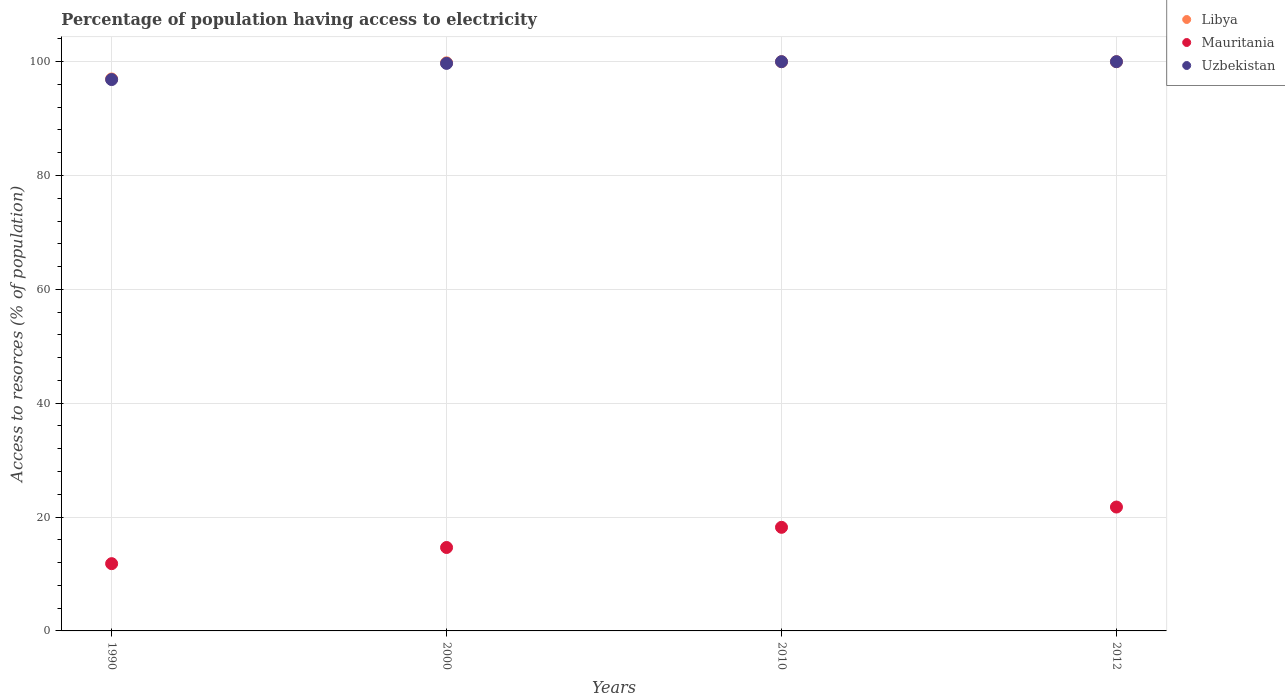How many different coloured dotlines are there?
Offer a terse response. 3. What is the percentage of population having access to electricity in Mauritania in 2000?
Provide a succinct answer. 14.66. Across all years, what is the maximum percentage of population having access to electricity in Libya?
Provide a succinct answer. 100. Across all years, what is the minimum percentage of population having access to electricity in Libya?
Give a very brief answer. 96.96. In which year was the percentage of population having access to electricity in Uzbekistan minimum?
Your answer should be compact. 1990. What is the total percentage of population having access to electricity in Mauritania in the graph?
Ensure brevity in your answer.  66.43. What is the difference between the percentage of population having access to electricity in Uzbekistan in 1990 and that in 2000?
Keep it short and to the point. -2.84. What is the difference between the percentage of population having access to electricity in Libya in 1990 and the percentage of population having access to electricity in Mauritania in 2010?
Give a very brief answer. 78.76. What is the average percentage of population having access to electricity in Libya per year?
Offer a very short reply. 99.19. In the year 2010, what is the difference between the percentage of population having access to electricity in Libya and percentage of population having access to electricity in Mauritania?
Your answer should be very brief. 81.8. What is the ratio of the percentage of population having access to electricity in Libya in 1990 to that in 2010?
Your answer should be very brief. 0.97. Is the percentage of population having access to electricity in Uzbekistan in 2000 less than that in 2010?
Offer a terse response. Yes. Is the difference between the percentage of population having access to electricity in Libya in 2000 and 2012 greater than the difference between the percentage of population having access to electricity in Mauritania in 2000 and 2012?
Provide a succinct answer. Yes. What is the difference between the highest and the lowest percentage of population having access to electricity in Uzbekistan?
Provide a short and direct response. 3.14. In how many years, is the percentage of population having access to electricity in Mauritania greater than the average percentage of population having access to electricity in Mauritania taken over all years?
Offer a terse response. 2. Is it the case that in every year, the sum of the percentage of population having access to electricity in Mauritania and percentage of population having access to electricity in Libya  is greater than the percentage of population having access to electricity in Uzbekistan?
Your response must be concise. Yes. Does the percentage of population having access to electricity in Mauritania monotonically increase over the years?
Your answer should be very brief. Yes. Is the percentage of population having access to electricity in Uzbekistan strictly greater than the percentage of population having access to electricity in Libya over the years?
Your response must be concise. No. Is the percentage of population having access to electricity in Mauritania strictly less than the percentage of population having access to electricity in Uzbekistan over the years?
Provide a short and direct response. Yes. How many dotlines are there?
Make the answer very short. 3. Where does the legend appear in the graph?
Offer a very short reply. Top right. What is the title of the graph?
Ensure brevity in your answer.  Percentage of population having access to electricity. Does "Latin America(developing only)" appear as one of the legend labels in the graph?
Ensure brevity in your answer.  No. What is the label or title of the X-axis?
Provide a short and direct response. Years. What is the label or title of the Y-axis?
Offer a terse response. Access to resorces (% of population). What is the Access to resorces (% of population) in Libya in 1990?
Offer a very short reply. 96.96. What is the Access to resorces (% of population) in Mauritania in 1990?
Make the answer very short. 11.82. What is the Access to resorces (% of population) of Uzbekistan in 1990?
Provide a succinct answer. 96.86. What is the Access to resorces (% of population) of Libya in 2000?
Your answer should be compact. 99.8. What is the Access to resorces (% of population) in Mauritania in 2000?
Ensure brevity in your answer.  14.66. What is the Access to resorces (% of population) in Uzbekistan in 2000?
Give a very brief answer. 99.7. What is the Access to resorces (% of population) of Libya in 2010?
Your response must be concise. 100. What is the Access to resorces (% of population) in Mauritania in 2010?
Your answer should be compact. 18.2. What is the Access to resorces (% of population) in Uzbekistan in 2010?
Your answer should be compact. 100. What is the Access to resorces (% of population) in Mauritania in 2012?
Keep it short and to the point. 21.76. What is the Access to resorces (% of population) of Uzbekistan in 2012?
Offer a very short reply. 100. Across all years, what is the maximum Access to resorces (% of population) in Libya?
Keep it short and to the point. 100. Across all years, what is the maximum Access to resorces (% of population) in Mauritania?
Your answer should be compact. 21.76. Across all years, what is the maximum Access to resorces (% of population) in Uzbekistan?
Provide a short and direct response. 100. Across all years, what is the minimum Access to resorces (% of population) of Libya?
Provide a short and direct response. 96.96. Across all years, what is the minimum Access to resorces (% of population) of Mauritania?
Make the answer very short. 11.82. Across all years, what is the minimum Access to resorces (% of population) in Uzbekistan?
Make the answer very short. 96.86. What is the total Access to resorces (% of population) of Libya in the graph?
Give a very brief answer. 396.76. What is the total Access to resorces (% of population) in Mauritania in the graph?
Keep it short and to the point. 66.43. What is the total Access to resorces (% of population) of Uzbekistan in the graph?
Your answer should be very brief. 396.56. What is the difference between the Access to resorces (% of population) in Libya in 1990 and that in 2000?
Offer a terse response. -2.84. What is the difference between the Access to resorces (% of population) in Mauritania in 1990 and that in 2000?
Give a very brief answer. -2.84. What is the difference between the Access to resorces (% of population) in Uzbekistan in 1990 and that in 2000?
Your response must be concise. -2.84. What is the difference between the Access to resorces (% of population) of Libya in 1990 and that in 2010?
Your answer should be very brief. -3.04. What is the difference between the Access to resorces (% of population) in Mauritania in 1990 and that in 2010?
Offer a very short reply. -6.38. What is the difference between the Access to resorces (% of population) in Uzbekistan in 1990 and that in 2010?
Provide a short and direct response. -3.14. What is the difference between the Access to resorces (% of population) in Libya in 1990 and that in 2012?
Your answer should be compact. -3.04. What is the difference between the Access to resorces (% of population) of Mauritania in 1990 and that in 2012?
Give a very brief answer. -9.95. What is the difference between the Access to resorces (% of population) in Uzbekistan in 1990 and that in 2012?
Ensure brevity in your answer.  -3.14. What is the difference between the Access to resorces (% of population) of Libya in 2000 and that in 2010?
Your answer should be very brief. -0.2. What is the difference between the Access to resorces (% of population) of Mauritania in 2000 and that in 2010?
Ensure brevity in your answer.  -3.54. What is the difference between the Access to resorces (% of population) in Mauritania in 2000 and that in 2012?
Provide a succinct answer. -7.11. What is the difference between the Access to resorces (% of population) of Uzbekistan in 2000 and that in 2012?
Ensure brevity in your answer.  -0.3. What is the difference between the Access to resorces (% of population) in Libya in 2010 and that in 2012?
Give a very brief answer. 0. What is the difference between the Access to resorces (% of population) of Mauritania in 2010 and that in 2012?
Ensure brevity in your answer.  -3.56. What is the difference between the Access to resorces (% of population) of Libya in 1990 and the Access to resorces (% of population) of Mauritania in 2000?
Keep it short and to the point. 82.3. What is the difference between the Access to resorces (% of population) in Libya in 1990 and the Access to resorces (% of population) in Uzbekistan in 2000?
Give a very brief answer. -2.74. What is the difference between the Access to resorces (% of population) in Mauritania in 1990 and the Access to resorces (% of population) in Uzbekistan in 2000?
Ensure brevity in your answer.  -87.88. What is the difference between the Access to resorces (% of population) in Libya in 1990 and the Access to resorces (% of population) in Mauritania in 2010?
Your response must be concise. 78.76. What is the difference between the Access to resorces (% of population) in Libya in 1990 and the Access to resorces (% of population) in Uzbekistan in 2010?
Provide a succinct answer. -3.04. What is the difference between the Access to resorces (% of population) in Mauritania in 1990 and the Access to resorces (% of population) in Uzbekistan in 2010?
Provide a short and direct response. -88.18. What is the difference between the Access to resorces (% of population) in Libya in 1990 and the Access to resorces (% of population) in Mauritania in 2012?
Keep it short and to the point. 75.2. What is the difference between the Access to resorces (% of population) in Libya in 1990 and the Access to resorces (% of population) in Uzbekistan in 2012?
Your response must be concise. -3.04. What is the difference between the Access to resorces (% of population) in Mauritania in 1990 and the Access to resorces (% of population) in Uzbekistan in 2012?
Provide a succinct answer. -88.18. What is the difference between the Access to resorces (% of population) of Libya in 2000 and the Access to resorces (% of population) of Mauritania in 2010?
Provide a succinct answer. 81.6. What is the difference between the Access to resorces (% of population) of Mauritania in 2000 and the Access to resorces (% of population) of Uzbekistan in 2010?
Keep it short and to the point. -85.34. What is the difference between the Access to resorces (% of population) in Libya in 2000 and the Access to resorces (% of population) in Mauritania in 2012?
Give a very brief answer. 78.04. What is the difference between the Access to resorces (% of population) of Libya in 2000 and the Access to resorces (% of population) of Uzbekistan in 2012?
Provide a succinct answer. -0.2. What is the difference between the Access to resorces (% of population) of Mauritania in 2000 and the Access to resorces (% of population) of Uzbekistan in 2012?
Your answer should be compact. -85.34. What is the difference between the Access to resorces (% of population) of Libya in 2010 and the Access to resorces (% of population) of Mauritania in 2012?
Your answer should be very brief. 78.24. What is the difference between the Access to resorces (% of population) of Libya in 2010 and the Access to resorces (% of population) of Uzbekistan in 2012?
Your answer should be very brief. 0. What is the difference between the Access to resorces (% of population) in Mauritania in 2010 and the Access to resorces (% of population) in Uzbekistan in 2012?
Offer a terse response. -81.8. What is the average Access to resorces (% of population) of Libya per year?
Your answer should be compact. 99.19. What is the average Access to resorces (% of population) in Mauritania per year?
Your answer should be compact. 16.61. What is the average Access to resorces (% of population) of Uzbekistan per year?
Your answer should be very brief. 99.14. In the year 1990, what is the difference between the Access to resorces (% of population) in Libya and Access to resorces (% of population) in Mauritania?
Your answer should be compact. 85.14. In the year 1990, what is the difference between the Access to resorces (% of population) of Libya and Access to resorces (% of population) of Uzbekistan?
Your answer should be compact. 0.1. In the year 1990, what is the difference between the Access to resorces (% of population) in Mauritania and Access to resorces (% of population) in Uzbekistan?
Provide a short and direct response. -85.04. In the year 2000, what is the difference between the Access to resorces (% of population) of Libya and Access to resorces (% of population) of Mauritania?
Keep it short and to the point. 85.14. In the year 2000, what is the difference between the Access to resorces (% of population) in Libya and Access to resorces (% of population) in Uzbekistan?
Provide a short and direct response. 0.1. In the year 2000, what is the difference between the Access to resorces (% of population) of Mauritania and Access to resorces (% of population) of Uzbekistan?
Make the answer very short. -85.04. In the year 2010, what is the difference between the Access to resorces (% of population) in Libya and Access to resorces (% of population) in Mauritania?
Ensure brevity in your answer.  81.8. In the year 2010, what is the difference between the Access to resorces (% of population) of Mauritania and Access to resorces (% of population) of Uzbekistan?
Provide a short and direct response. -81.8. In the year 2012, what is the difference between the Access to resorces (% of population) in Libya and Access to resorces (% of population) in Mauritania?
Your answer should be compact. 78.24. In the year 2012, what is the difference between the Access to resorces (% of population) in Mauritania and Access to resorces (% of population) in Uzbekistan?
Provide a succinct answer. -78.24. What is the ratio of the Access to resorces (% of population) in Libya in 1990 to that in 2000?
Make the answer very short. 0.97. What is the ratio of the Access to resorces (% of population) of Mauritania in 1990 to that in 2000?
Offer a very short reply. 0.81. What is the ratio of the Access to resorces (% of population) in Uzbekistan in 1990 to that in 2000?
Your response must be concise. 0.97. What is the ratio of the Access to resorces (% of population) of Libya in 1990 to that in 2010?
Offer a terse response. 0.97. What is the ratio of the Access to resorces (% of population) in Mauritania in 1990 to that in 2010?
Offer a very short reply. 0.65. What is the ratio of the Access to resorces (% of population) of Uzbekistan in 1990 to that in 2010?
Ensure brevity in your answer.  0.97. What is the ratio of the Access to resorces (% of population) in Libya in 1990 to that in 2012?
Offer a very short reply. 0.97. What is the ratio of the Access to resorces (% of population) of Mauritania in 1990 to that in 2012?
Provide a succinct answer. 0.54. What is the ratio of the Access to resorces (% of population) in Uzbekistan in 1990 to that in 2012?
Offer a very short reply. 0.97. What is the ratio of the Access to resorces (% of population) in Mauritania in 2000 to that in 2010?
Give a very brief answer. 0.81. What is the ratio of the Access to resorces (% of population) of Libya in 2000 to that in 2012?
Your response must be concise. 1. What is the ratio of the Access to resorces (% of population) of Mauritania in 2000 to that in 2012?
Offer a very short reply. 0.67. What is the ratio of the Access to resorces (% of population) of Uzbekistan in 2000 to that in 2012?
Make the answer very short. 1. What is the ratio of the Access to resorces (% of population) in Mauritania in 2010 to that in 2012?
Your response must be concise. 0.84. What is the ratio of the Access to resorces (% of population) in Uzbekistan in 2010 to that in 2012?
Your answer should be very brief. 1. What is the difference between the highest and the second highest Access to resorces (% of population) in Mauritania?
Your response must be concise. 3.56. What is the difference between the highest and the lowest Access to resorces (% of population) of Libya?
Provide a succinct answer. 3.04. What is the difference between the highest and the lowest Access to resorces (% of population) in Mauritania?
Ensure brevity in your answer.  9.95. What is the difference between the highest and the lowest Access to resorces (% of population) of Uzbekistan?
Your answer should be compact. 3.14. 